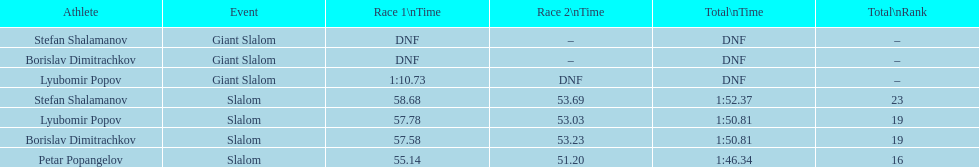Who is at the highest level in rank? Petar Popangelov. 